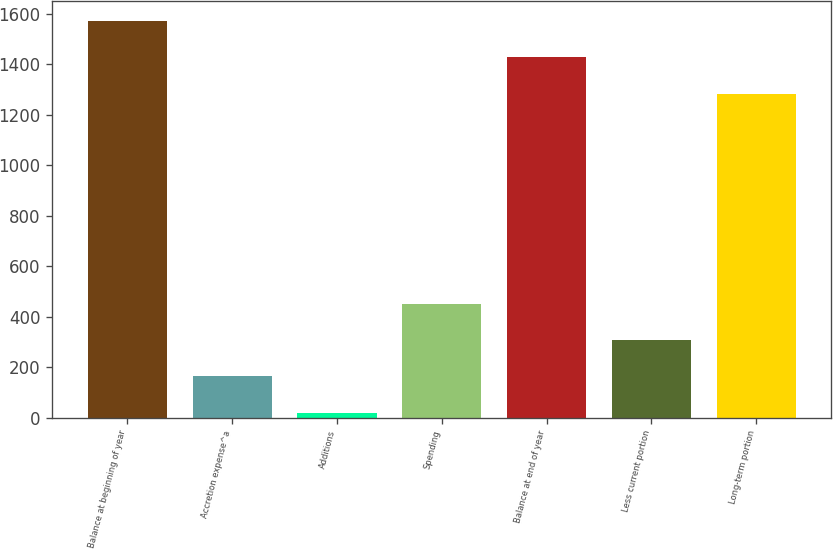Convert chart to OTSL. <chart><loc_0><loc_0><loc_500><loc_500><bar_chart><fcel>Balance at beginning of year<fcel>Accretion expense^a<fcel>Additions<fcel>Spending<fcel>Balance at end of year<fcel>Less current portion<fcel>Long-term portion<nl><fcel>1573<fcel>163.5<fcel>19<fcel>452.5<fcel>1428.5<fcel>308<fcel>1284<nl></chart> 